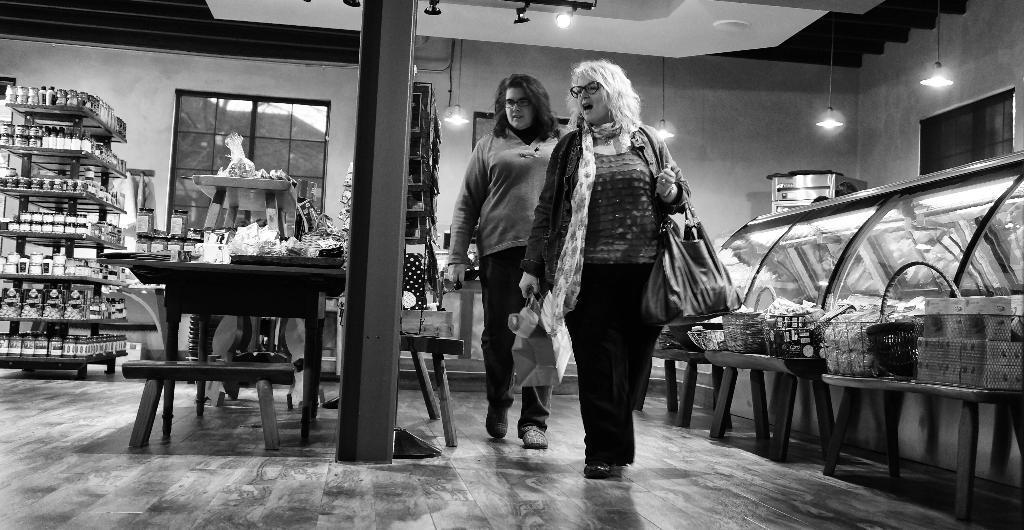Can you describe this image briefly? This is the picture of a mart in which there are some partitions of some items like we have a desk on which there are some bottles and a desk on which there are other items and two ladies walking and holding the bag in the mart. 